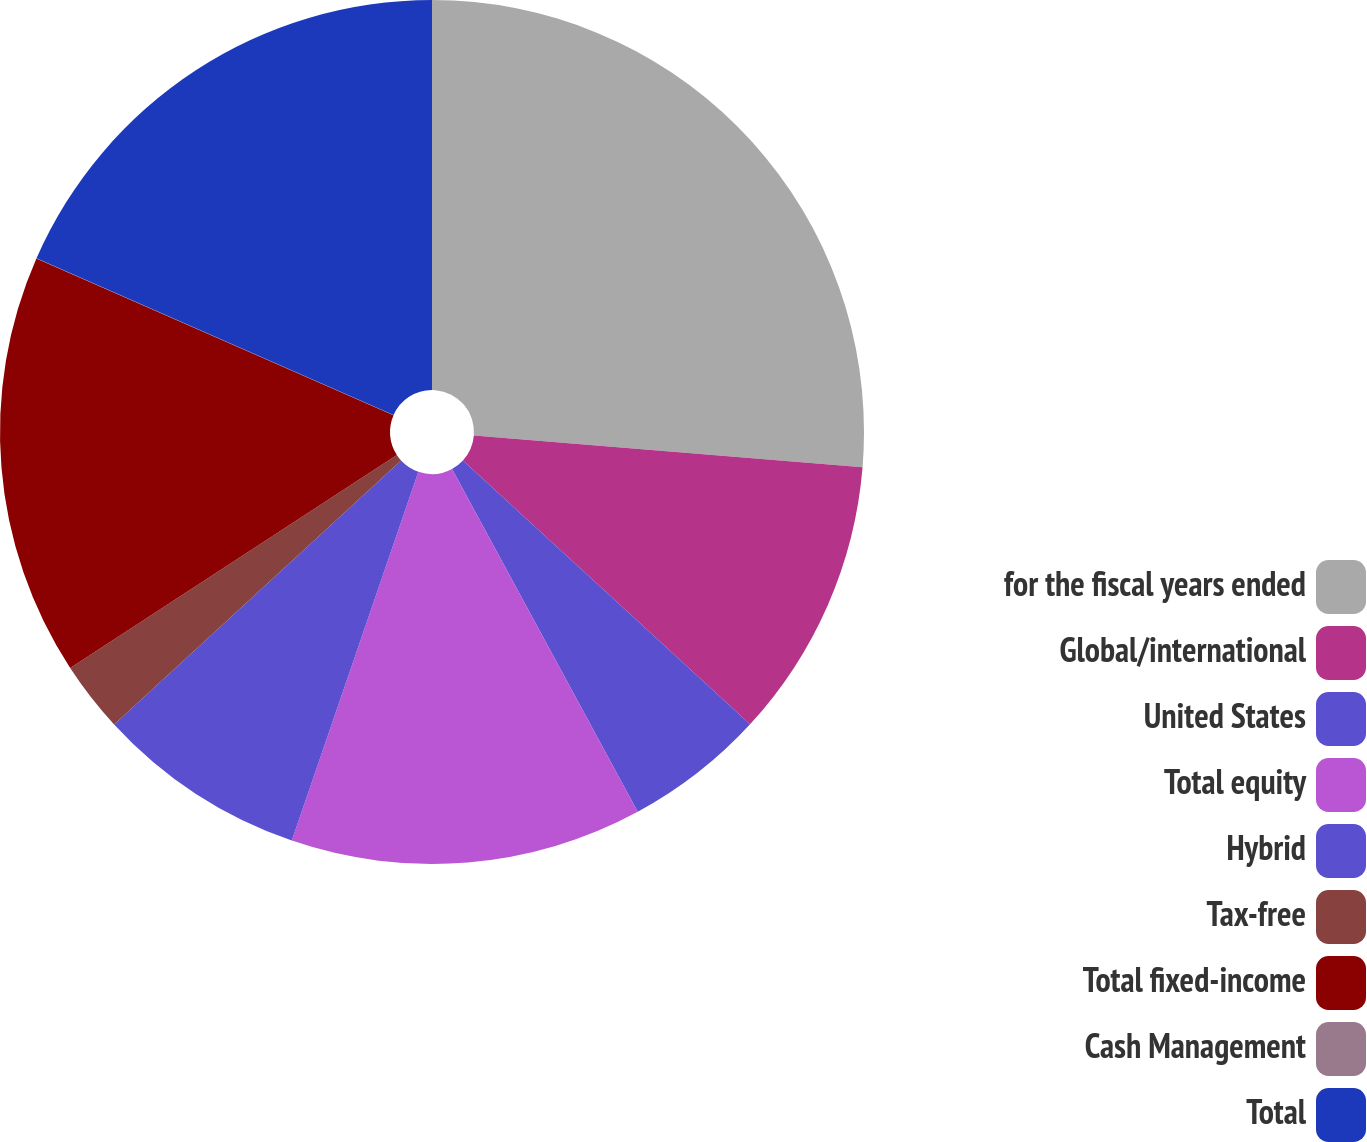<chart> <loc_0><loc_0><loc_500><loc_500><pie_chart><fcel>for the fiscal years ended<fcel>Global/international<fcel>United States<fcel>Total equity<fcel>Hybrid<fcel>Tax-free<fcel>Total fixed-income<fcel>Cash Management<fcel>Total<nl><fcel>26.3%<fcel>10.53%<fcel>5.27%<fcel>13.16%<fcel>7.9%<fcel>2.64%<fcel>15.78%<fcel>0.01%<fcel>18.41%<nl></chart> 